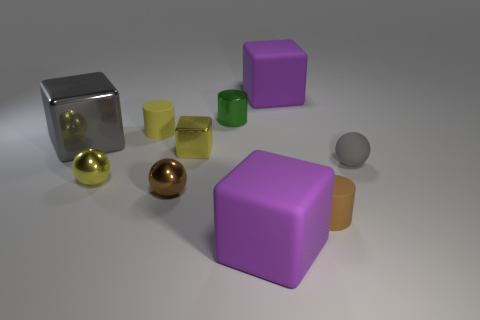The purple object that is behind the small brown object that is in front of the brown metal ball is made of what material?
Make the answer very short. Rubber. There is a rubber object that is the same color as the small cube; what shape is it?
Keep it short and to the point. Cylinder. Are there any small things made of the same material as the gray sphere?
Make the answer very short. Yes. Are the yellow cylinder and the thing to the right of the tiny brown matte thing made of the same material?
Offer a very short reply. Yes. What is the color of the metal cube that is the same size as the brown matte object?
Make the answer very short. Yellow. There is a gray object to the left of the yellow metallic object on the right side of the brown shiny thing; what is its size?
Provide a short and direct response. Large. Does the large shiny cube have the same color as the cube that is in front of the tiny gray ball?
Offer a very short reply. No. Are there fewer gray cubes that are on the right side of the big gray thing than small gray objects?
Provide a short and direct response. Yes. What number of other things are the same size as the brown rubber thing?
Ensure brevity in your answer.  6. There is a purple object behind the large gray metallic thing; is it the same shape as the small gray object?
Provide a succinct answer. No. 